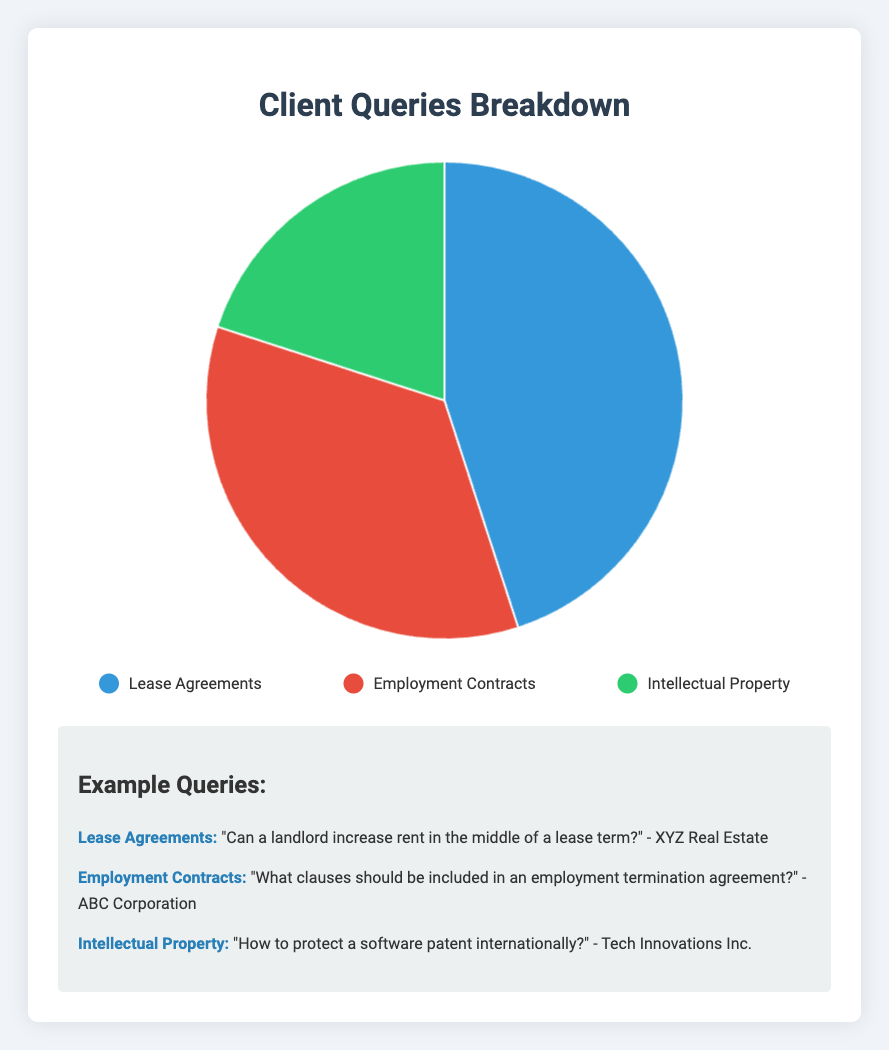Which category has the highest percentage of client queries? By looking at the size of the pie chart slices, we see that Lease Agreements is the largest slice with 45%.
Answer: Lease Agreements How much greater is the percentage of Lease Agreements compared to Employment Contracts? Lease Agreements have 45% and Employment Contracts have 35%. The difference is 45% - 35% = 10%.
Answer: 10% What is the total percentage of queries related to Lease Agreements and Intellectual Property combined? Lease Agreements account for 45% and Intellectual Property account for 20%. The total combined percentage is 45% + 20% = 65%.
Answer: 65% Which category has the smallest representation in client queries? By comparing the sizes of the slices, the smallest slice represents Intellectual Property at 20%.
Answer: Intellectual Property What is the difference in percentage between Employment Contracts and Intellectual Property queries? Employment Contracts have 35% and Intellectual Property have 20%. The difference is 35% - 20% = 15%.
Answer: 15% What is the average percentage of client queries for all categories? Add up the percentages for all categories: 45% (Lease Agreements) + 35% (Employment Contracts) + 20% (Intellectual Property) = 100%. The average is 100% / 3 categories = 33.33%.
Answer: 33.33% Which category is represented by the red slice in the pie chart? The legend shows that the red slice represents Employment Contracts.
Answer: Employment Contracts 